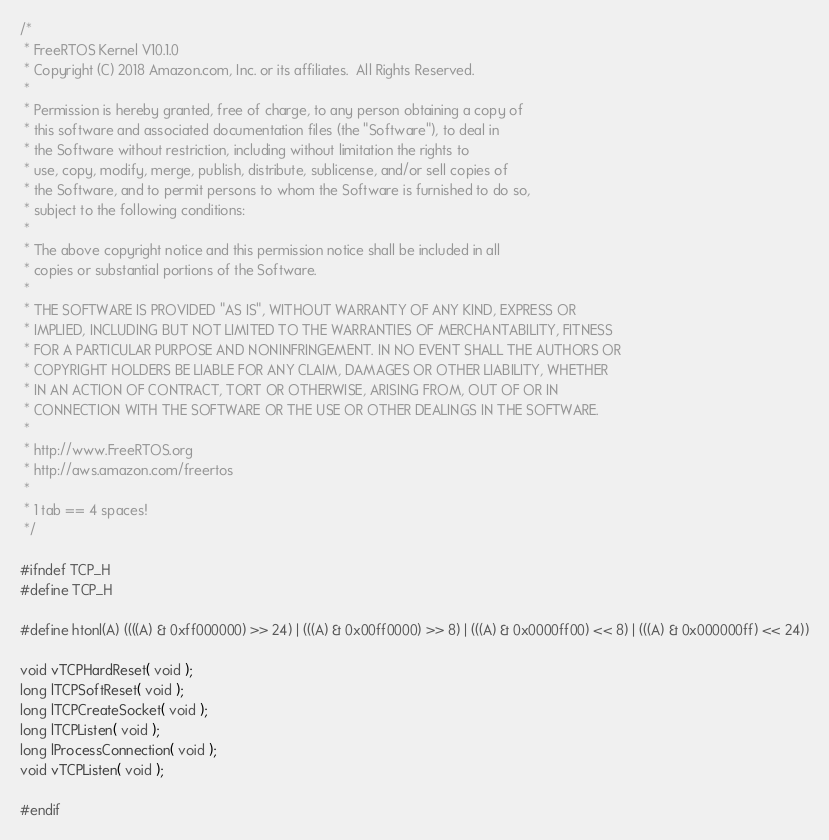Convert code to text. <code><loc_0><loc_0><loc_500><loc_500><_C_>/*
 * FreeRTOS Kernel V10.1.0
 * Copyright (C) 2018 Amazon.com, Inc. or its affiliates.  All Rights Reserved.
 *
 * Permission is hereby granted, free of charge, to any person obtaining a copy of
 * this software and associated documentation files (the "Software"), to deal in
 * the Software without restriction, including without limitation the rights to
 * use, copy, modify, merge, publish, distribute, sublicense, and/or sell copies of
 * the Software, and to permit persons to whom the Software is furnished to do so,
 * subject to the following conditions:
 *
 * The above copyright notice and this permission notice shall be included in all
 * copies or substantial portions of the Software.
 *
 * THE SOFTWARE IS PROVIDED "AS IS", WITHOUT WARRANTY OF ANY KIND, EXPRESS OR
 * IMPLIED, INCLUDING BUT NOT LIMITED TO THE WARRANTIES OF MERCHANTABILITY, FITNESS
 * FOR A PARTICULAR PURPOSE AND NONINFRINGEMENT. IN NO EVENT SHALL THE AUTHORS OR
 * COPYRIGHT HOLDERS BE LIABLE FOR ANY CLAIM, DAMAGES OR OTHER LIABILITY, WHETHER
 * IN AN ACTION OF CONTRACT, TORT OR OTHERWISE, ARISING FROM, OUT OF OR IN
 * CONNECTION WITH THE SOFTWARE OR THE USE OR OTHER DEALINGS IN THE SOFTWARE.
 *
 * http://www.FreeRTOS.org
 * http://aws.amazon.com/freertos
 *
 * 1 tab == 4 spaces!
 */

#ifndef TCP_H
#define TCP_H

#define htonl(A) ((((A) & 0xff000000) >> 24) | (((A) & 0x00ff0000) >> 8) | (((A) & 0x0000ff00) << 8) | (((A) & 0x000000ff) << 24))

void vTCPHardReset( void );
long lTCPSoftReset( void );
long lTCPCreateSocket( void );
long lTCPListen( void );
long lProcessConnection( void );
void vTCPListen( void );

#endif
</code> 